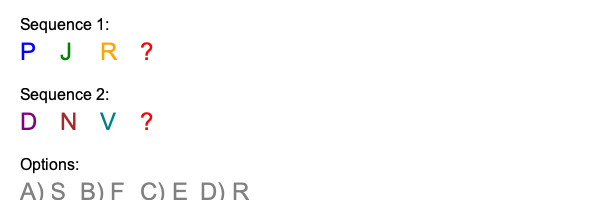In the Estonian tech scene, two sequences of popular programming languages and frameworks are shown. What is the most likely letter to complete both sequences? To solve this problem, we need to identify the pattern in each sequence and determine which option best fits both:

1. Sequence 1 analysis:
   P - likely represents Python
   J - likely represents Java
   R - likely represents Ruby

2. Sequence 2 analysis:
   D - likely represents Django (Python web framework)
   N - likely represents Node.js (JavaScript runtime)
   V - likely represents Vue.js (JavaScript framework)

3. Pattern identification:
   Sequence 1 shows popular programming languages in Estonia.
   Sequence 2 shows popular web frameworks or technologies in Estonia.

4. Missing element analysis:
   The missing element should be a programming language (to fit Sequence 1) that also has a popular web framework or technology associated with it (to fit Sequence 2).

5. Evaluating options:
   A) S - could represent Scala, but not commonly associated with a web framework
   B) F - could represent F#, but not commonly used in web development
   C) E - likely represents Express.js, a popular web framework for Node.js
   D) R - already present in Sequence 1, so unlikely to be the answer

6. Conclusion:
   Option C (E for Express.js) is the most likely answer, as it completes both sequences:
   - In Sequence 1, it can represent JavaScript, a popular programming language
   - In Sequence 2, it represents Express.js, a popular web framework

This choice aligns with the Estonian tech scene, where JavaScript and its ecosystem (including Node.js and Express.js) are widely used.
Answer: C) E 